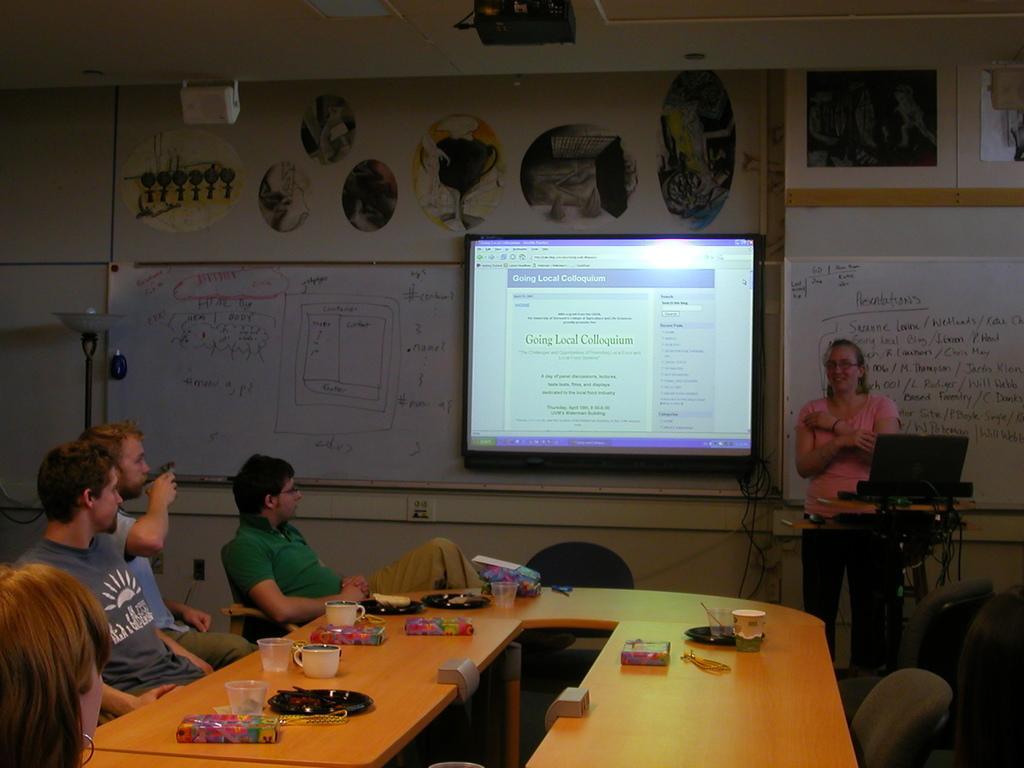In one or two sentences, can you explain what this image depicts? In this picture we can see some persons sitting on the chairs. This is the table. On the table there some plates, cups, and glasses. Here we can see a woman who is standing on the floor. And this is the screen. And there is a wall. 